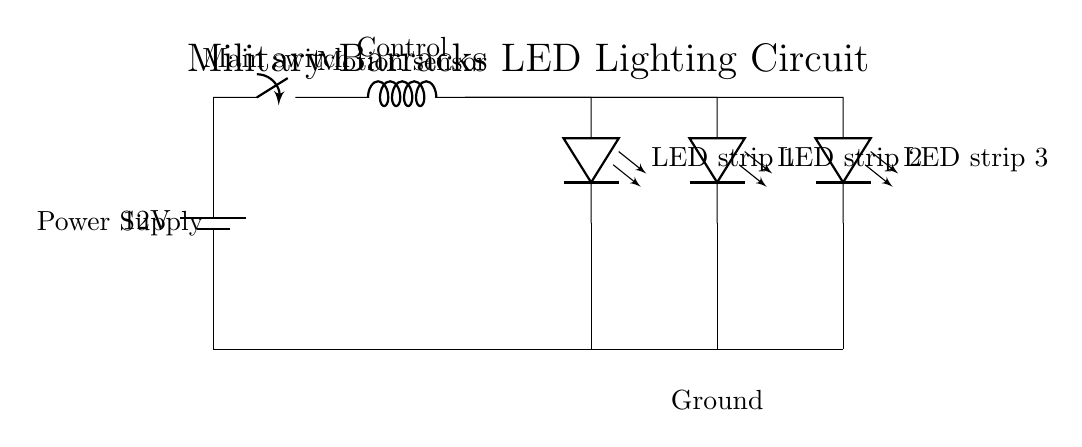What is the voltage of this circuit? The voltage is twelve volts, which is indicated by the power source in the circuit diagram. It shows a battery labeled with twelve volts at the top left corner.
Answer: twelve volts What component controls the LED strips? The component that controls the LED strips is the motion sensor, which is positioned after the main switch in the sequence of connections. It detects movement to activate the LEDs.
Answer: motion sensor How many LED strips are connected in this circuit? There are three LED strips connected in this circuit, as indicated by the three separate LED symbols extending from the motion sensor in the diagram.
Answer: three What is the function of the main switch in this circuit? The main switch functions as a control mechanism that can turn the circuit on or off, allowing for power to flow from the battery to the motion sensor and LED strips when closed.
Answer: control mechanism What happens when the motion sensor detects movement? When the motion sensor detects movement, it completes the circuit from the battery through the main switch to the LED strips, causing them to illuminate based on the motion detected.
Answer: illuminate 